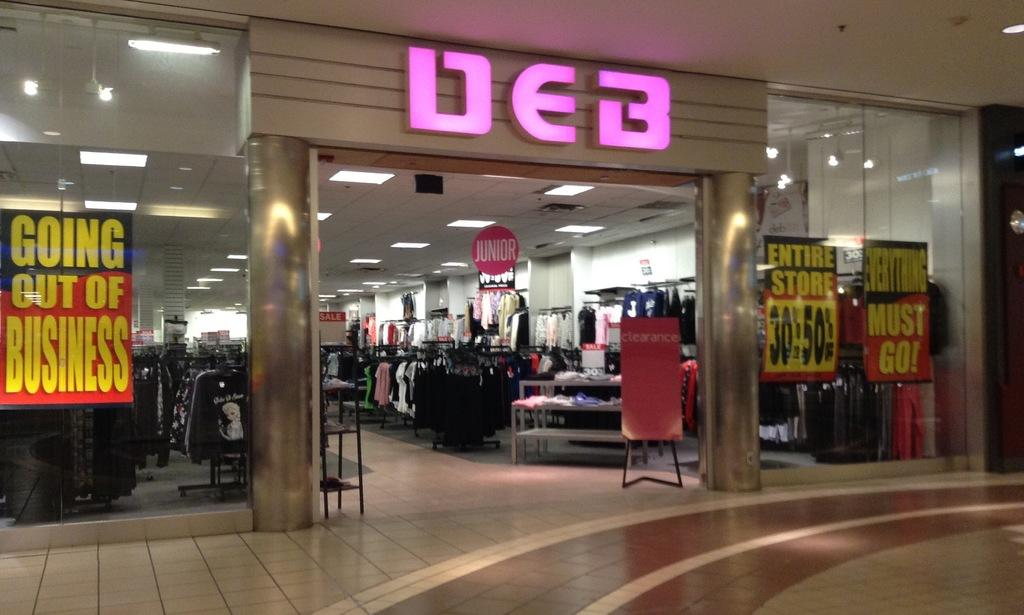What is located in the middle of the image? There is an entrance in the middle of the image. What type of establishment does the entrance resemble? The entrance looks like a store. What can be seen inside the entrance? There are clothes visible inside the entrance. What type of whistle can be heard coming from the entrance in the image? There is no whistle present in the image, and therefore no such sound can be heard. 